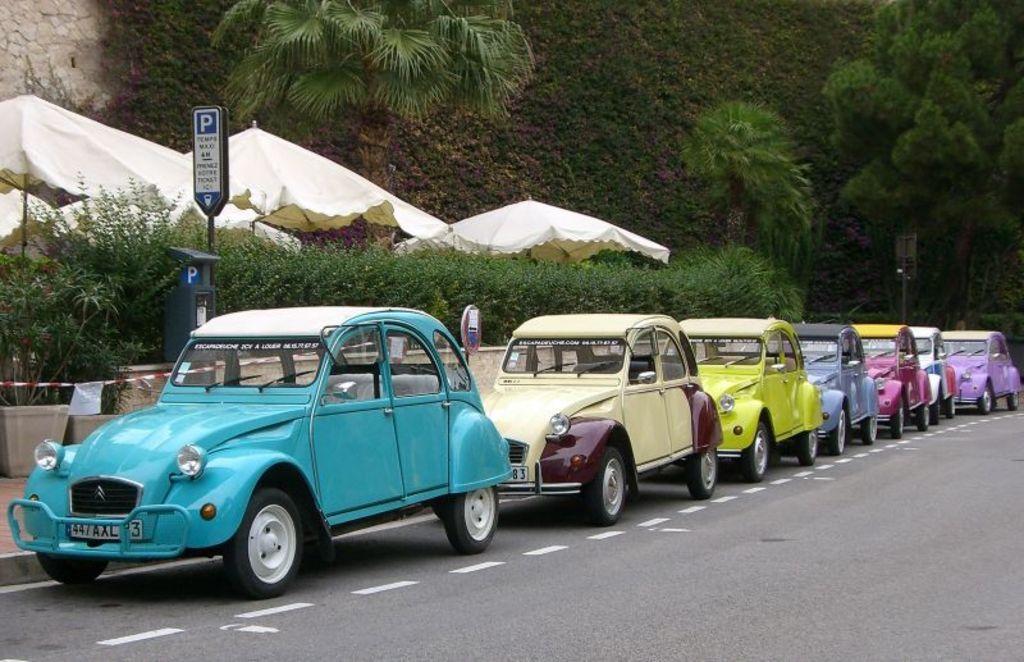In one or two sentences, can you explain what this image depicts? In this image we can see there are some cars parked in a side of a road. In the background there are some trees. 